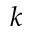Convert formula to latex. <formula><loc_0><loc_0><loc_500><loc_500>k</formula> 